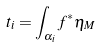Convert formula to latex. <formula><loc_0><loc_0><loc_500><loc_500>t _ { i } = \int _ { \alpha _ { i } } f ^ { * } \eta _ { M }</formula> 